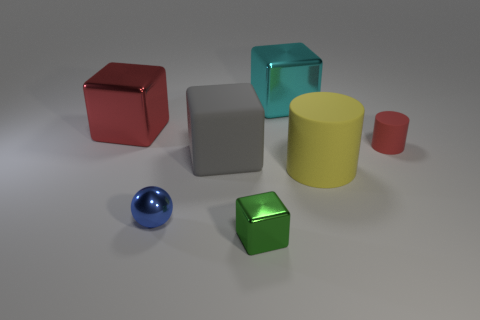Subtract all cyan metallic blocks. How many blocks are left? 3 Add 2 small rubber things. How many objects exist? 9 Subtract all yellow cubes. Subtract all red cylinders. How many cubes are left? 4 Subtract all cyan shiny cylinders. Subtract all matte cylinders. How many objects are left? 5 Add 4 big cylinders. How many big cylinders are left? 5 Add 1 big gray things. How many big gray things exist? 2 Subtract 0 green cylinders. How many objects are left? 7 Subtract all cubes. How many objects are left? 3 